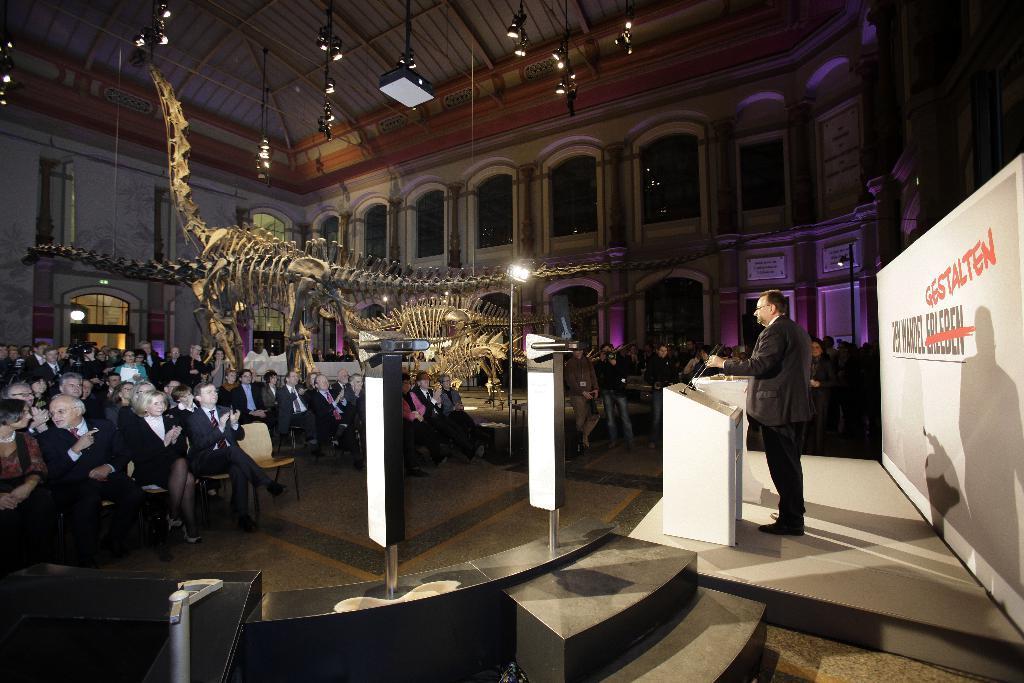Could you give a brief overview of what you see in this image? In the image we can see there are many people around, they are wearing clothes, they are sitting and some of them are standing. Here we can see a podium, microphones and a poster. There are even many lights and there is a bone sculpture of a dinosaur. Here we can see windows, door and footpath. 